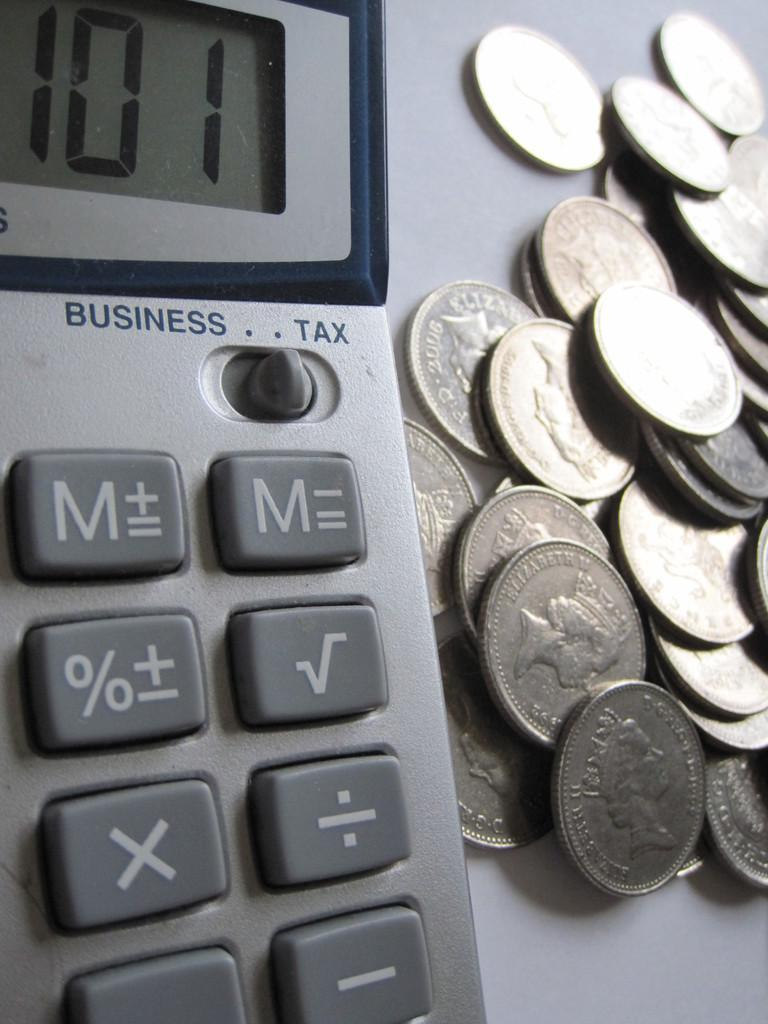Provide a one-sentence caption for the provided image. A bunch of coins sit next to a calculator, which reads 101. 